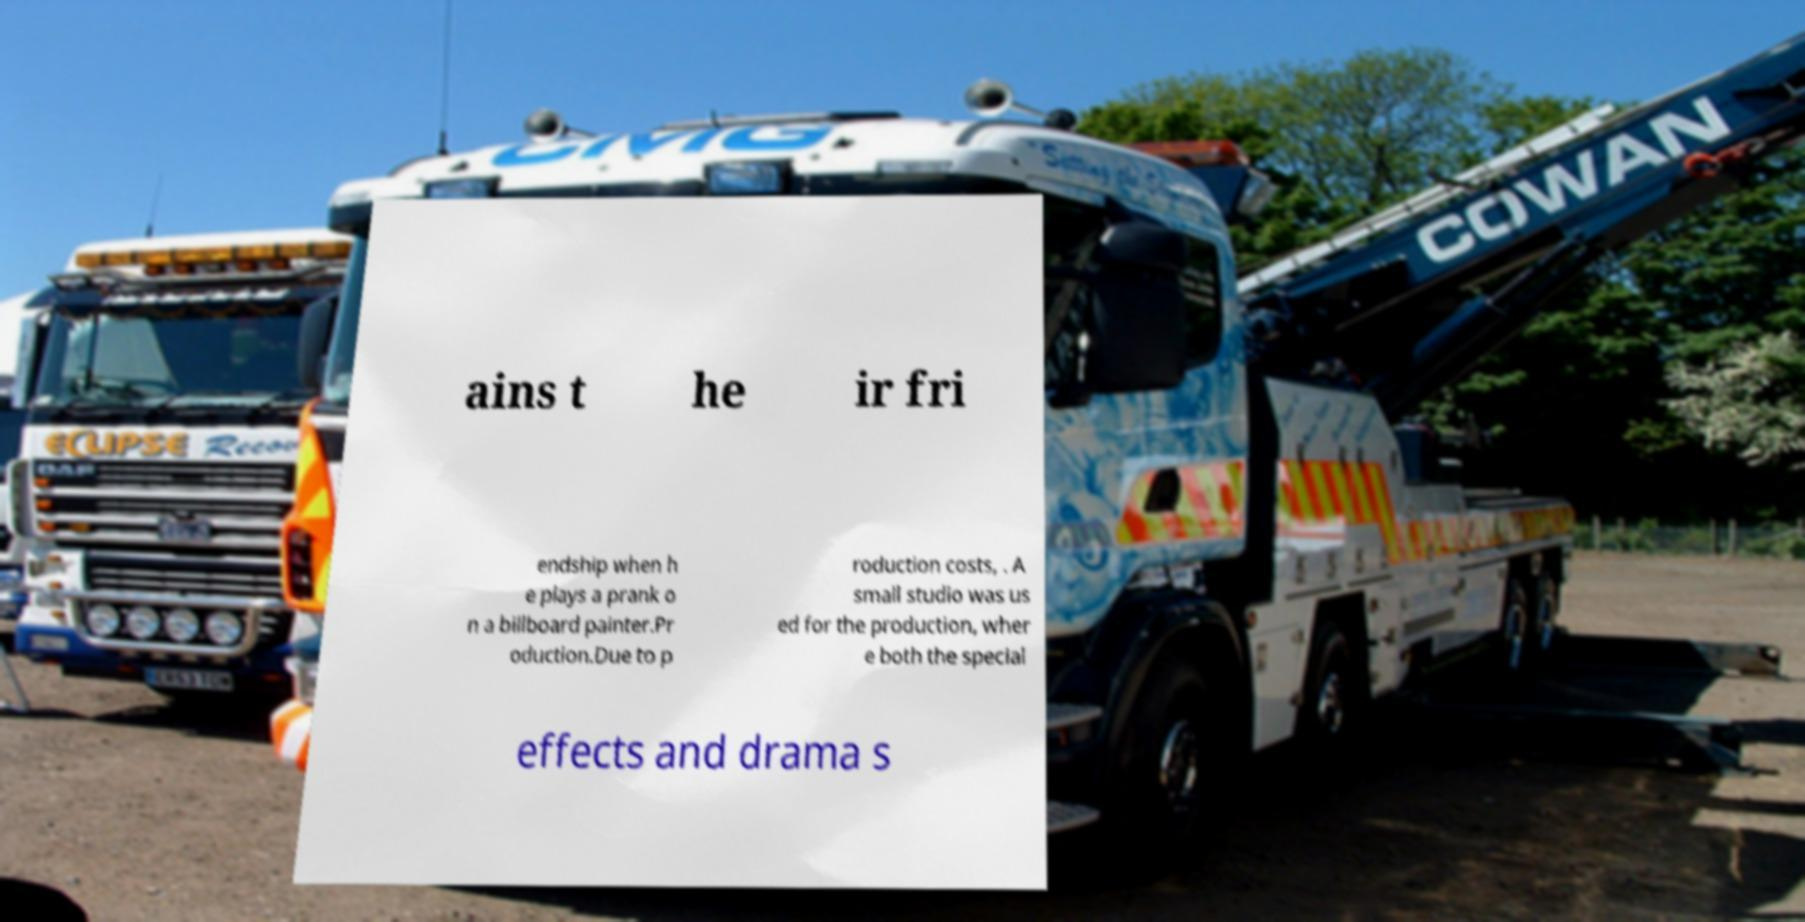Can you accurately transcribe the text from the provided image for me? ains t he ir fri endship when h e plays a prank o n a billboard painter.Pr oduction.Due to p roduction costs, . A small studio was us ed for the production, wher e both the special effects and drama s 